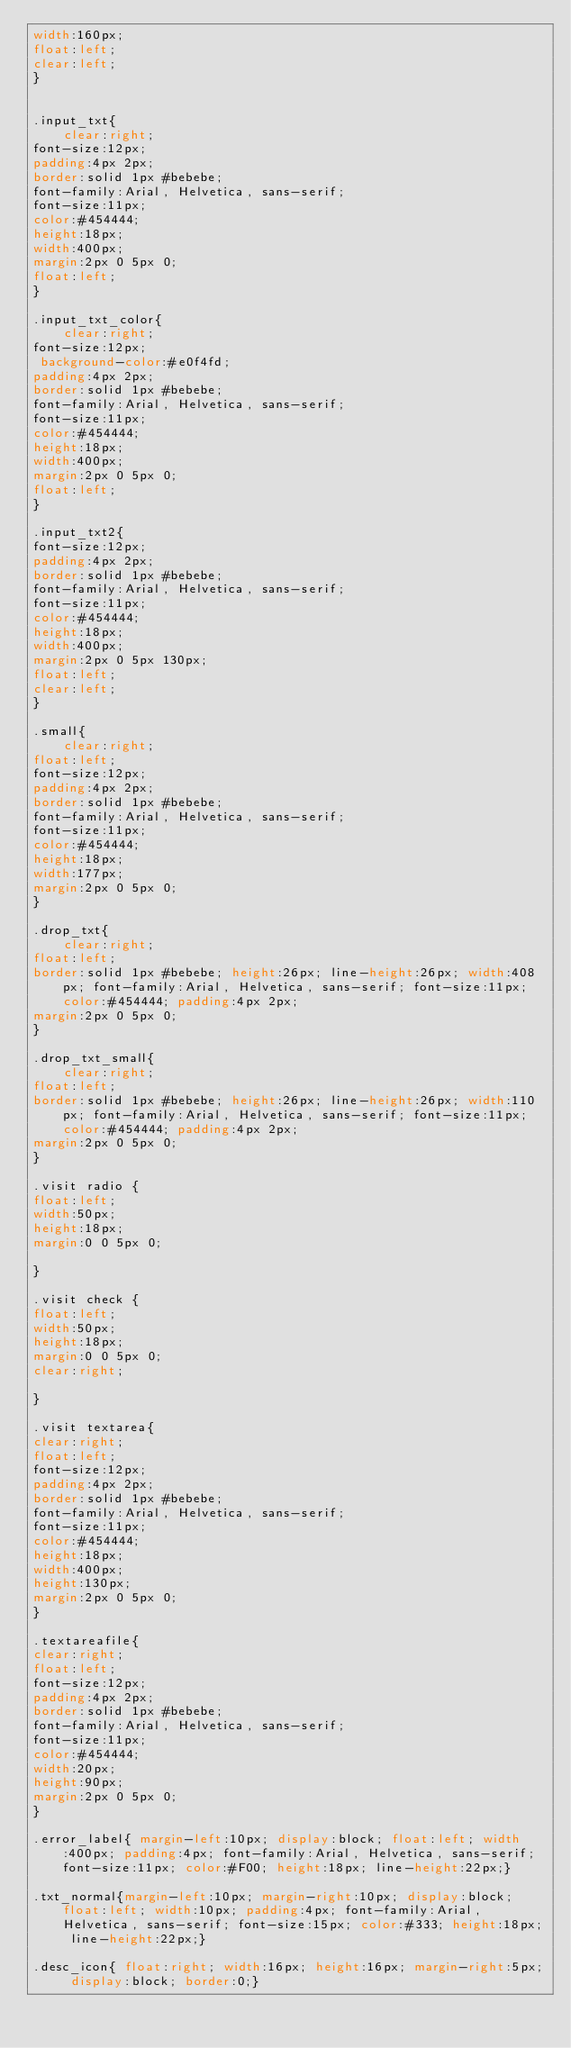<code> <loc_0><loc_0><loc_500><loc_500><_CSS_>width:160px;
float:left;
clear:left;
}


.input_txt{
	clear:right;
font-size:12px;
padding:4px 2px;
border:solid 1px #bebebe;
font-family:Arial, Helvetica, sans-serif;
font-size:11px;
color:#454444;
height:18px;
width:400px;
margin:2px 0 5px 0;
float:left;
}

.input_txt_color{
	clear:right;
font-size:12px;
 background-color:#e0f4fd;
padding:4px 2px;
border:solid 1px #bebebe;
font-family:Arial, Helvetica, sans-serif;
font-size:11px;
color:#454444;
height:18px;
width:400px;
margin:2px 0 5px 0;
float:left;
}

.input_txt2{
font-size:12px;
padding:4px 2px;
border:solid 1px #bebebe;
font-family:Arial, Helvetica, sans-serif;
font-size:11px;
color:#454444;
height:18px;
width:400px;
margin:2px 0 5px 130px;
float:left;
clear:left;
}

.small{
	clear:right;
float:left;
font-size:12px;
padding:4px 2px;
border:solid 1px #bebebe;
font-family:Arial, Helvetica, sans-serif;
font-size:11px;
color:#454444;
height:18px;
width:177px;
margin:2px 0 5px 0;
}

.drop_txt{
	clear:right;
float:left;
border:solid 1px #bebebe; height:26px; line-height:26px; width:408px; font-family:Arial, Helvetica, sans-serif; font-size:11px; color:#454444; padding:4px 2px;
margin:2px 0 5px 0;
}

.drop_txt_small{
	clear:right;
float:left;
border:solid 1px #bebebe; height:26px; line-height:26px; width:110px; font-family:Arial, Helvetica, sans-serif; font-size:11px; color:#454444; padding:4px 2px;
margin:2px 0 5px 0;
}

.visit radio {
float:left;
width:50px;
height:18px;
margin:0 0 5px 0;

}

.visit check {
float:left;
width:50px;
height:18px;
margin:0 0 5px 0;
clear:right;

}

.visit textarea{
clear:right;
float:left;
font-size:12px;
padding:4px 2px;
border:solid 1px #bebebe;
font-family:Arial, Helvetica, sans-serif;
font-size:11px;
color:#454444;
height:18px;
width:400px;
height:130px;
margin:2px 0 5px 0;
}

.textareafile{
clear:right;
float:left;
font-size:12px;
padding:4px 2px;
border:solid 1px #bebebe;
font-family:Arial, Helvetica, sans-serif;
font-size:11px;
color:#454444;
width:20px;
height:90px;
margin:2px 0 5px 0;
}

.error_label{ margin-left:10px; display:block; float:left; width:400px; padding:4px; font-family:Arial, Helvetica, sans-serif; font-size:11px; color:#F00; height:18px; line-height:22px;}

.txt_normal{margin-left:10px; margin-right:10px; display:block; float:left; width:10px; padding:4px; font-family:Arial, Helvetica, sans-serif; font-size:15px; color:#333; height:18px; line-height:22px;}

.desc_icon{ float:right; width:16px; height:16px; margin-right:5px; display:block; border:0;}
</code> 